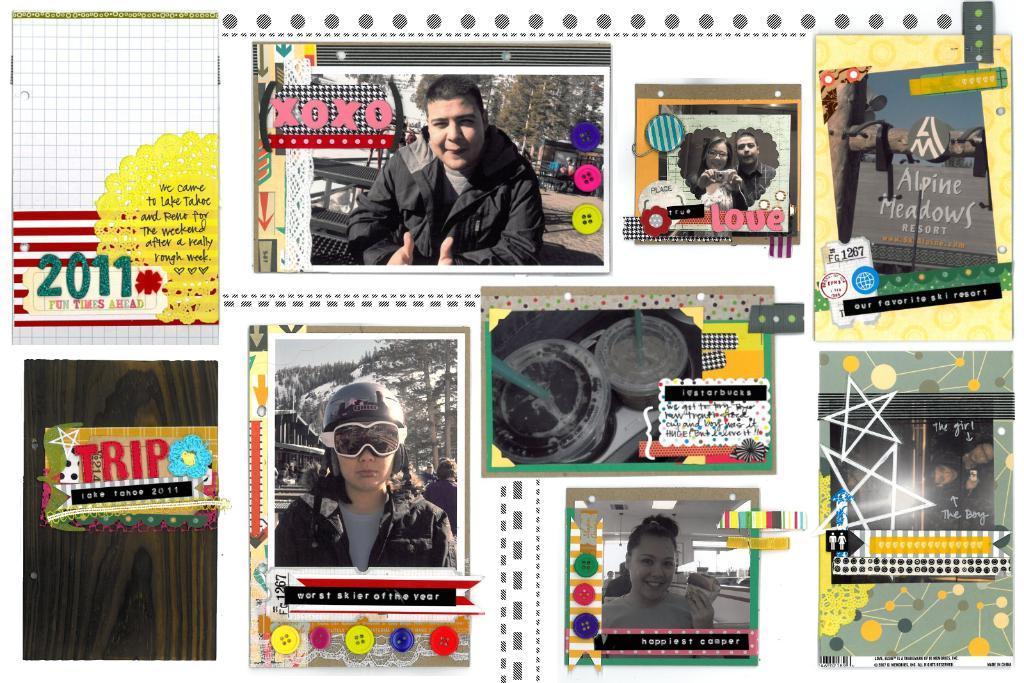In one or two sentences, can you explain what this image depicts? In this edited image there are pictures of people and glasses. There is also text in the image. There are frames around the pictures and the text. 